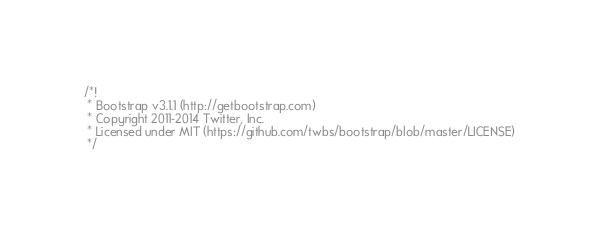Convert code to text. <code><loc_0><loc_0><loc_500><loc_500><_CSS_>/*!
 * Bootstrap v3.1.1 (http://getbootstrap.com)
 * Copyright 2011-2014 Twitter, Inc.
 * Licensed under MIT (https://github.com/twbs/bootstrap/blob/master/LICENSE)
 */
</code> 